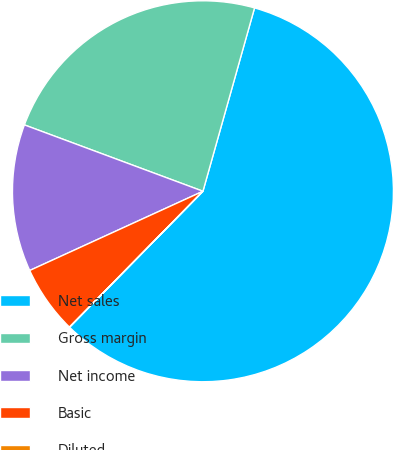Convert chart to OTSL. <chart><loc_0><loc_0><loc_500><loc_500><pie_chart><fcel>Net sales<fcel>Gross margin<fcel>Net income<fcel>Basic<fcel>Diluted<nl><fcel>57.98%<fcel>23.7%<fcel>12.49%<fcel>5.81%<fcel>0.01%<nl></chart> 